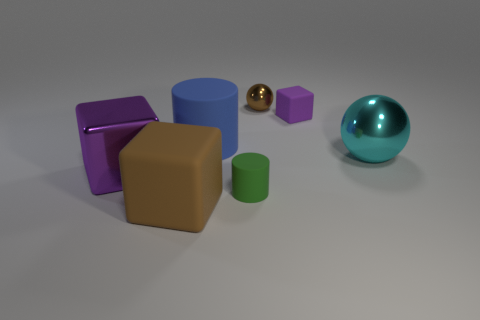Is the large blue cylinder made of the same material as the big brown block?
Provide a succinct answer. Yes. What number of spheres are either big cyan objects or small matte objects?
Offer a terse response. 1. What is the color of the large thing that is made of the same material as the blue cylinder?
Offer a very short reply. Brown. Is the number of purple shiny objects less than the number of large brown matte cylinders?
Offer a very short reply. No. Is the shape of the small thing in front of the tiny purple cube the same as the small rubber object behind the large metal ball?
Offer a terse response. No. How many objects are tiny green things or cyan metallic cylinders?
Offer a very short reply. 1. There is a metal sphere that is the same size as the blue object; what is its color?
Make the answer very short. Cyan. There is a purple cube that is in front of the cyan metal object; what number of large shiny cubes are behind it?
Your response must be concise. 0. How many large things are both right of the brown metal thing and behind the large cyan sphere?
Ensure brevity in your answer.  0. What number of things are brown spheres that are on the right side of the big rubber cylinder or cylinders behind the cyan metal ball?
Your answer should be compact. 2. 